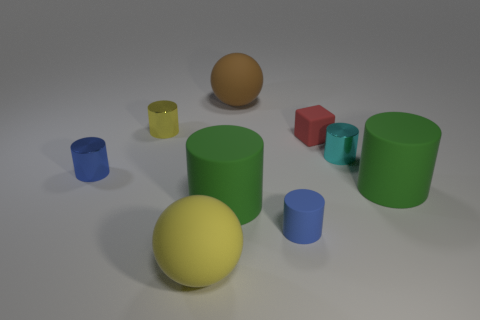Subtract all yellow cylinders. How many cylinders are left? 5 Subtract all big matte cylinders. How many cylinders are left? 4 Subtract all cyan cylinders. Subtract all purple balls. How many cylinders are left? 5 Add 1 big things. How many objects exist? 10 Subtract all cubes. How many objects are left? 8 Subtract 2 blue cylinders. How many objects are left? 7 Subtract all large green matte things. Subtract all matte objects. How many objects are left? 1 Add 8 blue shiny cylinders. How many blue shiny cylinders are left? 9 Add 6 big gray matte cylinders. How many big gray matte cylinders exist? 6 